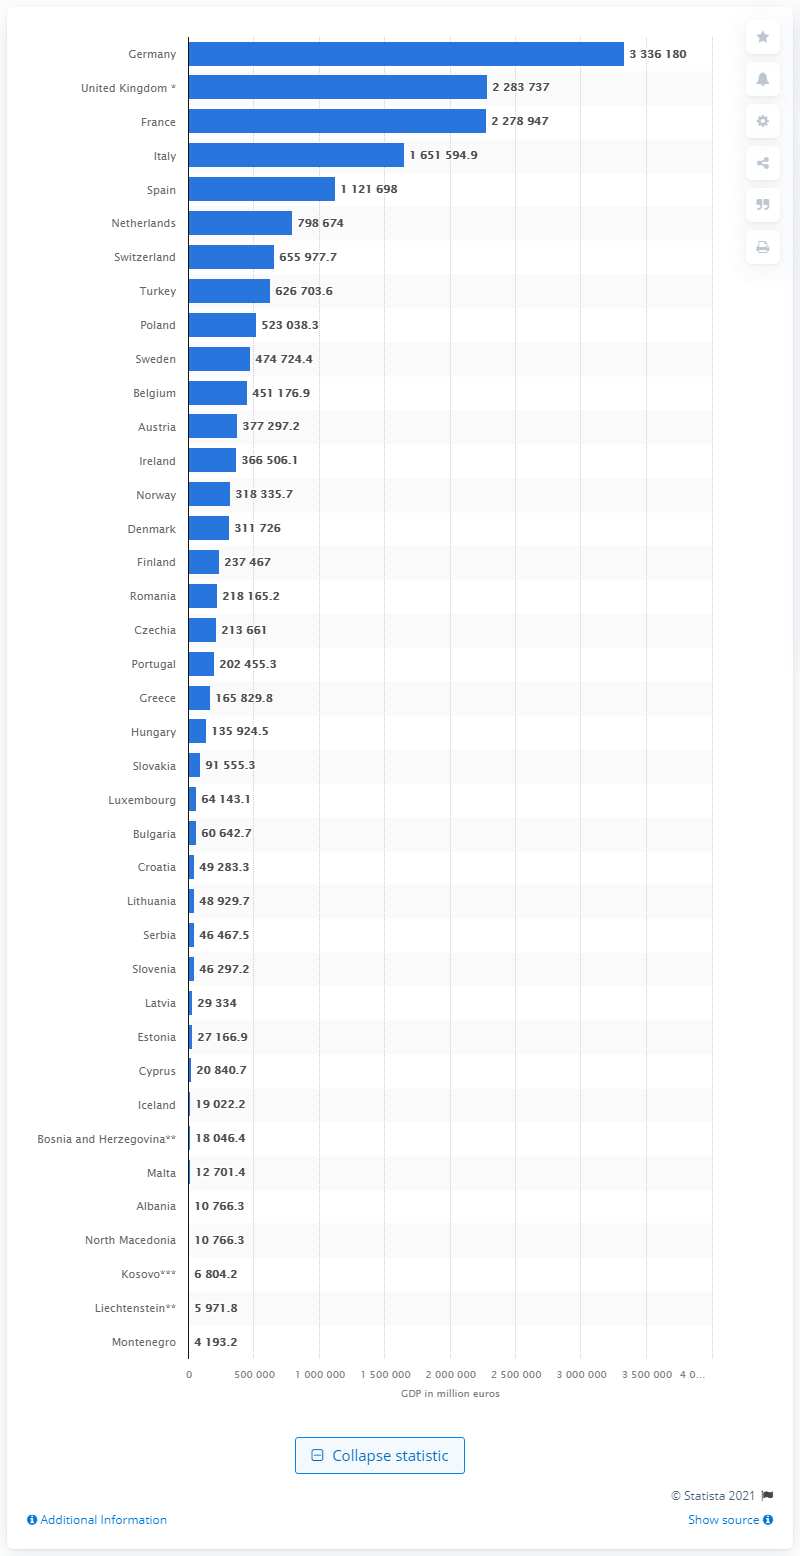Give some essential details in this illustration. Montenegro is the smallest economy in the Balkans. Montenegro's Gross Domestic Product (GDP) in 2020 was 4,193.2 million. 